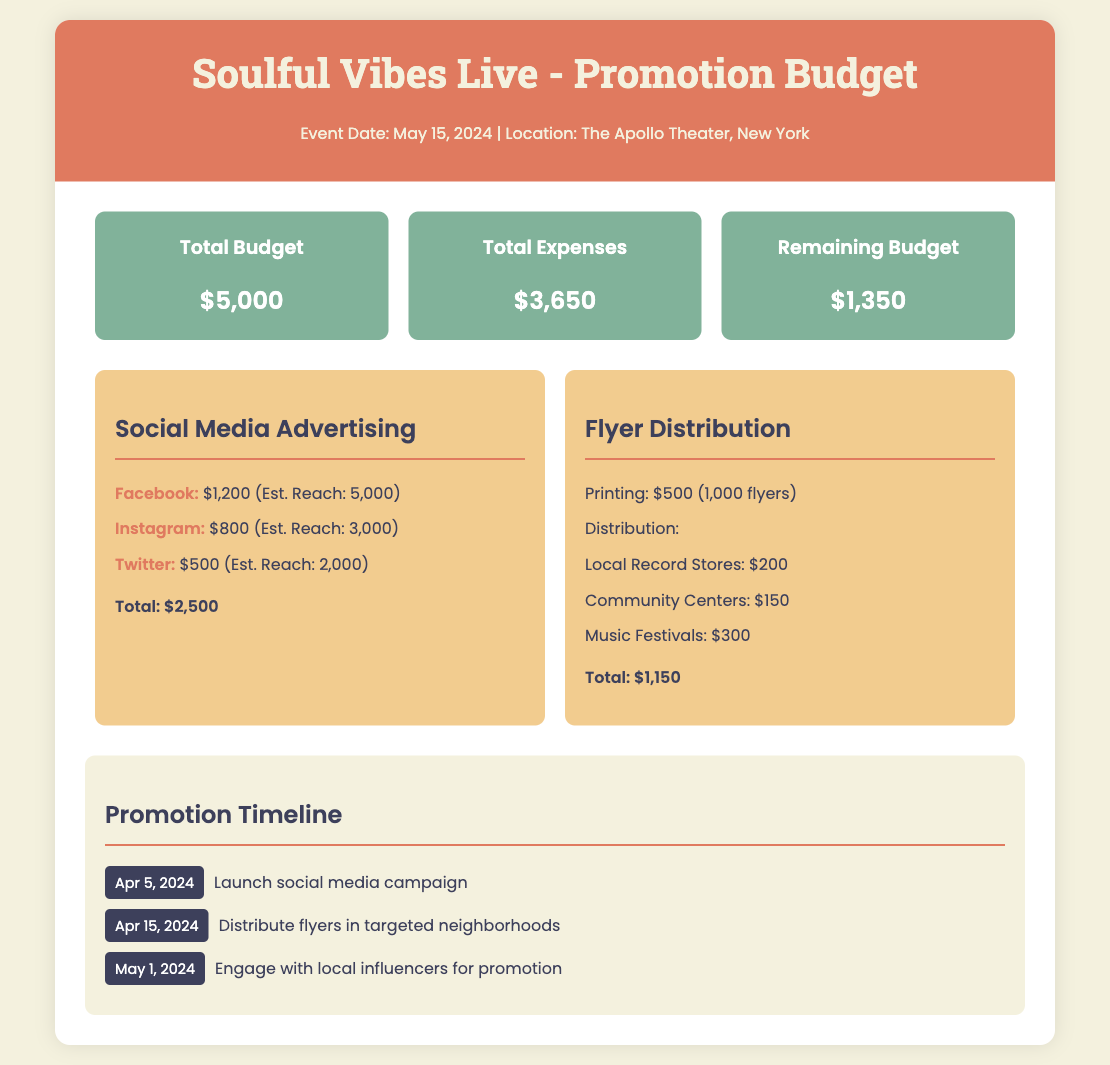What is the total budget? The total budget is explicitly stated in the document as part of the overview section.
Answer: $5,000 What is the total amount allocated for social media advertising? The document specifies the total amount for social media advertising in the respective section.
Answer: $2,500 When is the social media campaign scheduled to launch? The timeline section provides specific dates for promotional activities, including the launch date for social media campaigns.
Answer: Apr 5, 2024 How much is spent on flyer printing? The flyer distribution section breaks down the costs, including the printing cost for flyers.
Answer: $500 What is the estimated reach of Instagram advertising? The social media advertising section states the estimated reach for each platform, including Instagram.
Answer: 3,000 What is the remaining budget after expenses? This information is provided in the budget overview as the difference between the total budget and total expenses.
Answer: $1,350 How much is allocated for distribution to community centers? The flyer distribution section lists expenses, including the amount allocated for community centers.
Answer: $150 What is the total expense for flyer distribution? The document sums up the total cost for flyers and their distribution in the flyer distribution section.
Answer: $1,150 What is the date for distributing flyers in targeted neighborhoods? The timeline section lists dates for various promotional activities, including flyer distribution.
Answer: Apr 15, 2024 